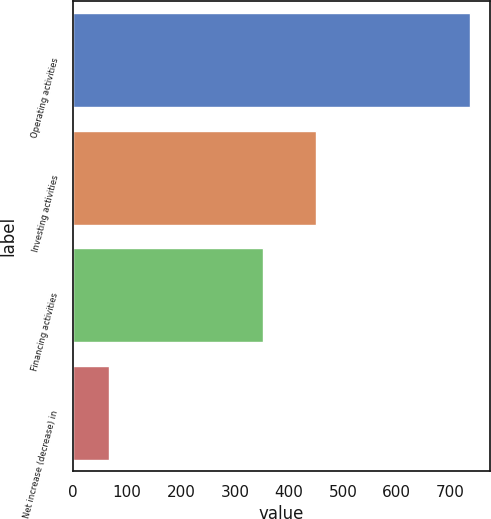Convert chart to OTSL. <chart><loc_0><loc_0><loc_500><loc_500><bar_chart><fcel>Operating activities<fcel>Investing activities<fcel>Financing activities<fcel>Net increase (decrease) in<nl><fcel>736.1<fcel>451.1<fcel>351.1<fcel>66.1<nl></chart> 